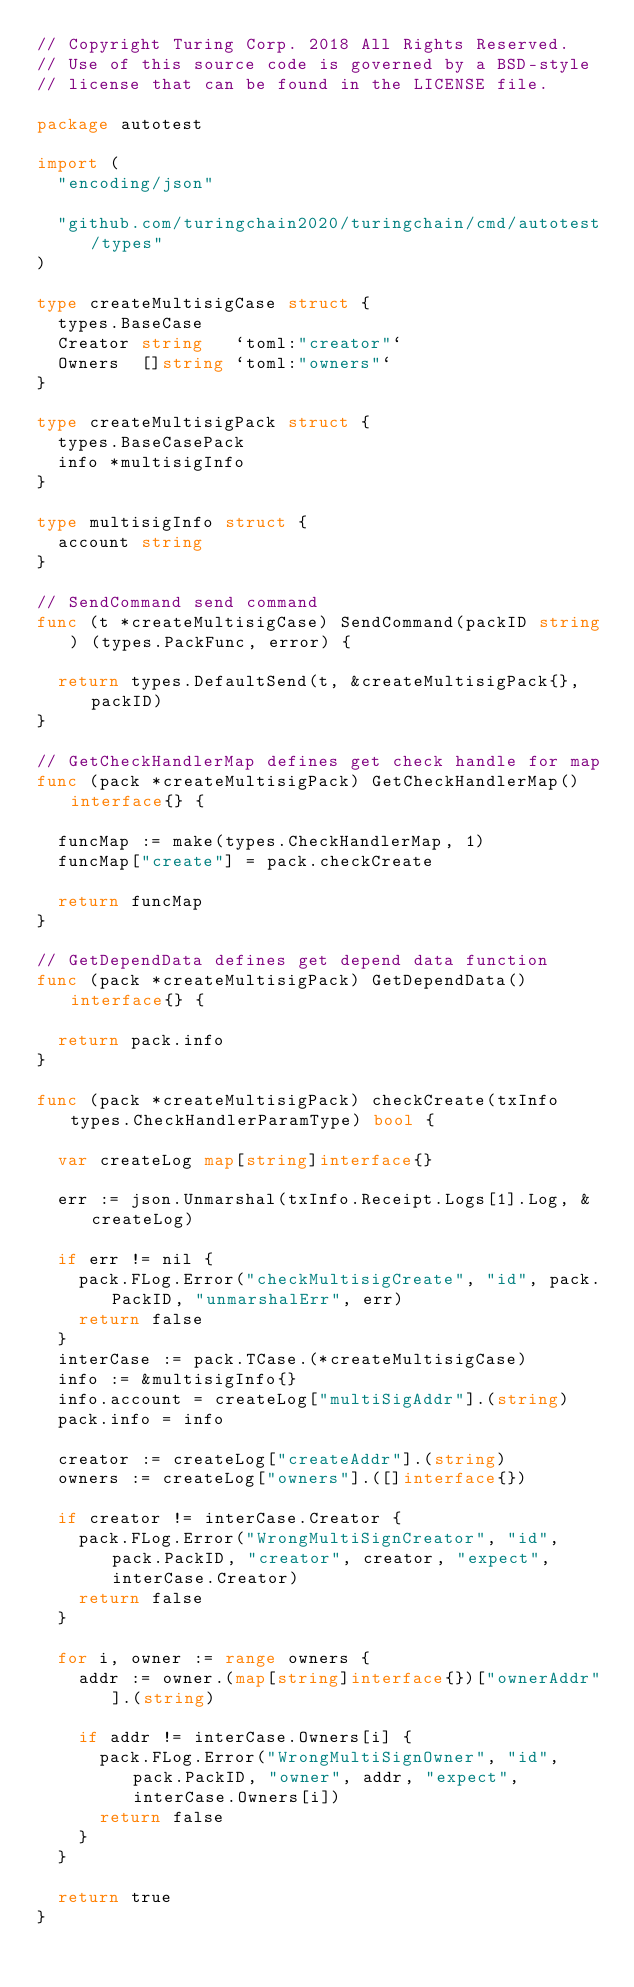<code> <loc_0><loc_0><loc_500><loc_500><_Go_>// Copyright Turing Corp. 2018 All Rights Reserved.
// Use of this source code is governed by a BSD-style
// license that can be found in the LICENSE file.

package autotest

import (
	"encoding/json"

	"github.com/turingchain2020/turingchain/cmd/autotest/types"
)

type createMultisigCase struct {
	types.BaseCase
	Creator string   `toml:"creator"`
	Owners  []string `toml:"owners"`
}

type createMultisigPack struct {
	types.BaseCasePack
	info *multisigInfo
}

type multisigInfo struct {
	account string
}

// SendCommand send command
func (t *createMultisigCase) SendCommand(packID string) (types.PackFunc, error) {

	return types.DefaultSend(t, &createMultisigPack{}, packID)
}

// GetCheckHandlerMap defines get check handle for map
func (pack *createMultisigPack) GetCheckHandlerMap() interface{} {

	funcMap := make(types.CheckHandlerMap, 1)
	funcMap["create"] = pack.checkCreate

	return funcMap
}

// GetDependData defines get depend data function
func (pack *createMultisigPack) GetDependData() interface{} {

	return pack.info
}

func (pack *createMultisigPack) checkCreate(txInfo types.CheckHandlerParamType) bool {

	var createLog map[string]interface{}

	err := json.Unmarshal(txInfo.Receipt.Logs[1].Log, &createLog)

	if err != nil {
		pack.FLog.Error("checkMultisigCreate", "id", pack.PackID, "unmarshalErr", err)
		return false
	}
	interCase := pack.TCase.(*createMultisigCase)
	info := &multisigInfo{}
	info.account = createLog["multiSigAddr"].(string)
	pack.info = info

	creator := createLog["createAddr"].(string)
	owners := createLog["owners"].([]interface{})

	if creator != interCase.Creator {
		pack.FLog.Error("WrongMultiSignCreator", "id", pack.PackID, "creator", creator, "expect", interCase.Creator)
		return false
	}

	for i, owner := range owners {
		addr := owner.(map[string]interface{})["ownerAddr"].(string)

		if addr != interCase.Owners[i] {
			pack.FLog.Error("WrongMultiSignOwner", "id", pack.PackID, "owner", addr, "expect", interCase.Owners[i])
			return false
		}
	}

	return true
}
</code> 